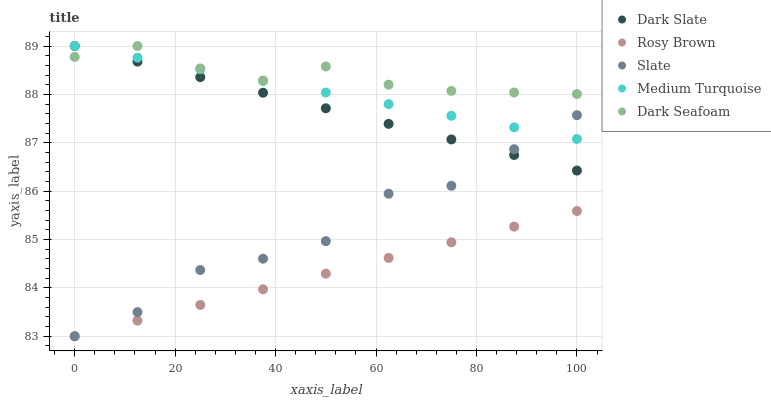Does Rosy Brown have the minimum area under the curve?
Answer yes or no. Yes. Does Dark Seafoam have the maximum area under the curve?
Answer yes or no. Yes. Does Slate have the minimum area under the curve?
Answer yes or no. No. Does Slate have the maximum area under the curve?
Answer yes or no. No. Is Dark Slate the smoothest?
Answer yes or no. Yes. Is Slate the roughest?
Answer yes or no. Yes. Is Rosy Brown the smoothest?
Answer yes or no. No. Is Rosy Brown the roughest?
Answer yes or no. No. Does Slate have the lowest value?
Answer yes or no. Yes. Does Dark Seafoam have the lowest value?
Answer yes or no. No. Does Medium Turquoise have the highest value?
Answer yes or no. Yes. Does Slate have the highest value?
Answer yes or no. No. Is Rosy Brown less than Dark Seafoam?
Answer yes or no. Yes. Is Dark Slate greater than Rosy Brown?
Answer yes or no. Yes. Does Slate intersect Rosy Brown?
Answer yes or no. Yes. Is Slate less than Rosy Brown?
Answer yes or no. No. Is Slate greater than Rosy Brown?
Answer yes or no. No. Does Rosy Brown intersect Dark Seafoam?
Answer yes or no. No. 